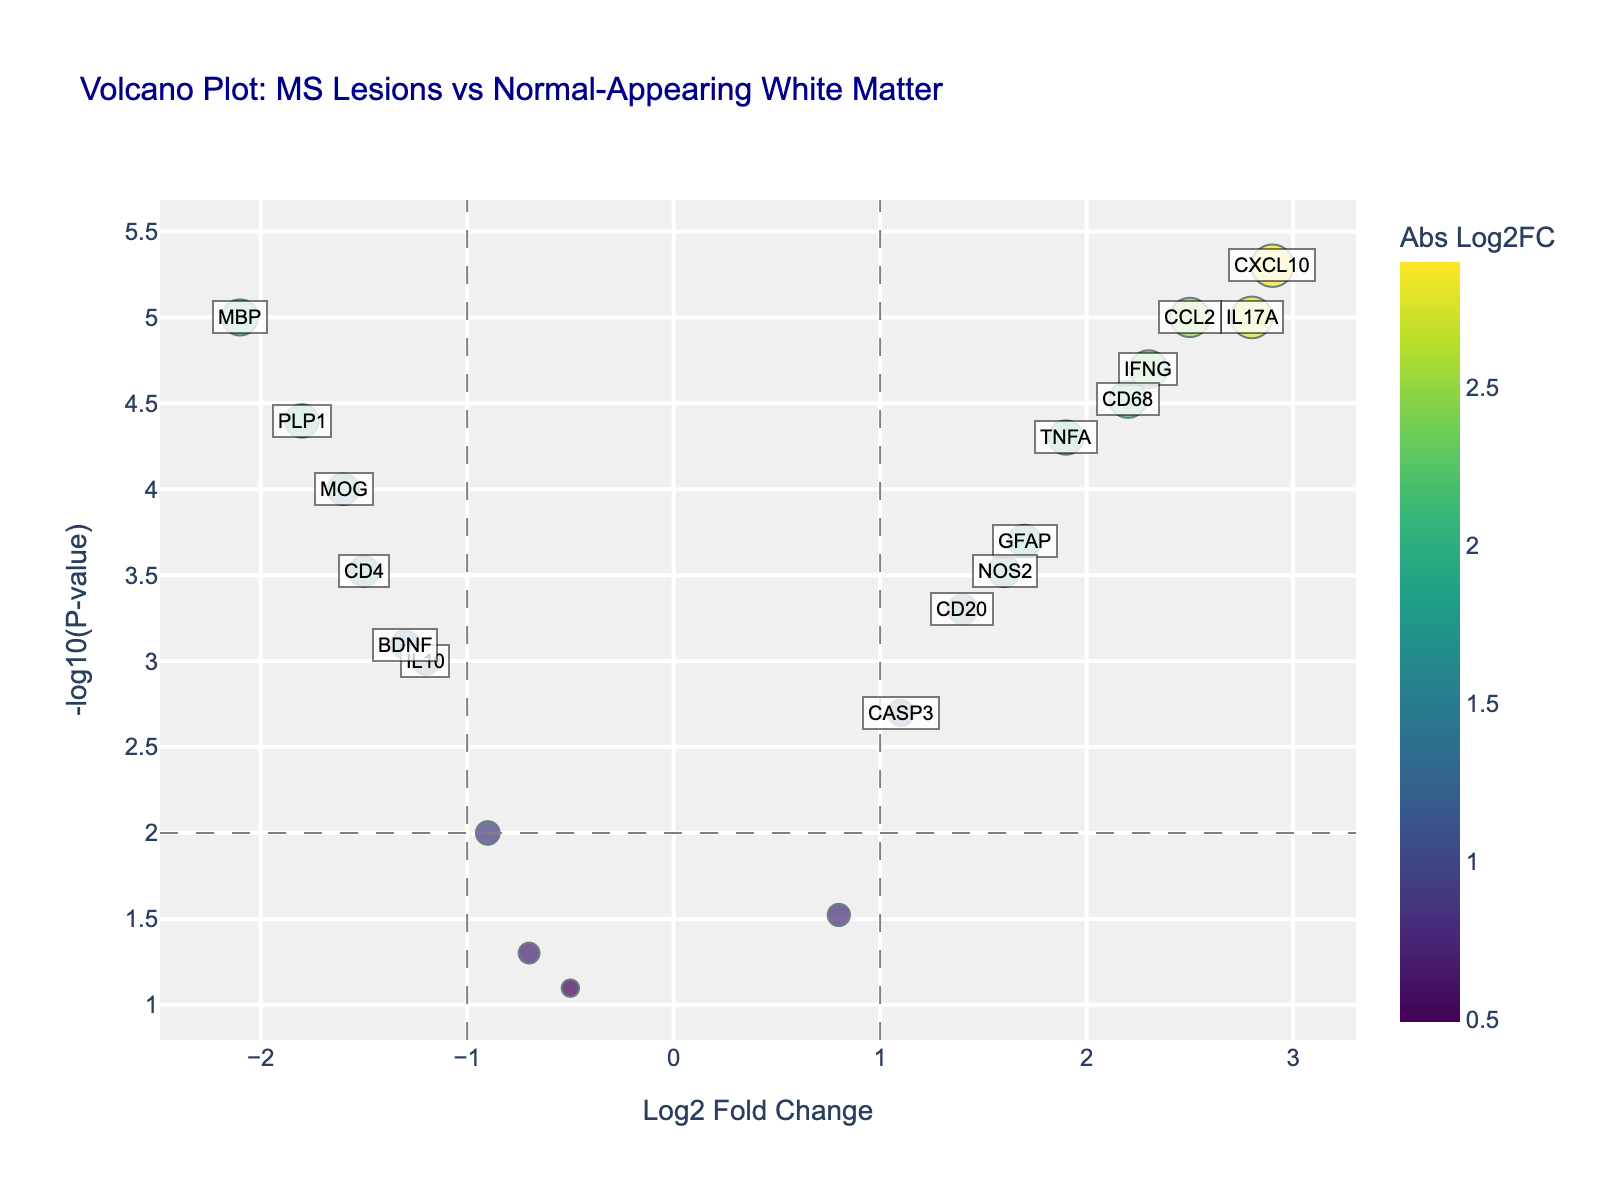What's the title of the plot? The title of the plot is displayed at the top of the figure. By looking at this position, we can see the title specified for the volcano plot.
Answer: Volcano Plot: MS Lesions vs Normal-Appearing White Matter How many genes have a log2 fold change greater than 1? On the horizontal axis, we see the genes distributed based on their log2 fold changes. Genes with a value greater than 1 are those to the right of the vertical threshold line at x=1. Counting these points provides the answer.
Answer: 7 Which gene has the highest -log10(p-value)? By identifying the point that is plotted highest on the vertical axis, we can find the gene with the maximum -log10(p-value). The hover text or annotations can confirm the gene's name.
Answer: CXCL10 Are there any genes with a -log10(p-value) less than 2? The horizontal axis allows us to see the values plotted. We need to check for any points that fall below the threshold line at y=2 to find these genes.
Answer: Yes What is the log2 fold change of the gene CD4? Locate the gene CD4 on the plot and refer to its position on the horizontal axis, which represents the log2 fold change. The hover text may also provide this information.
Answer: -1.5 Which gene has the lowest log2 fold change? By identifying the point furthest to the left on the x-axis, we can determine the gene with the lowest log2 fold change. The hover text or annotations can help confirm the gene's name.
Answer: MBP How many genes have a significant p-value (p<0.05)? On the vertical axis, a significant p-value translates to a -log10(p-value) greater than approximately 1.3. Counting all points above this value will give the total number of significant genes.
Answer: 18 Compare the log2 fold change of IL17A and TNFA. Which one is higher? By locating both IL17A and TNFA on the plot and comparing their positions on the horizontal axis, we can determine which gene has a higher log2 fold change.
Answer: IL17A What is the general trend shown in the plot? Observing the distribution of points can help discern if there is a particular trend. For example, whether more genes tend to have positive or negative log2 fold changes, and how closely these correspond to low p-values.
Answer: More genes tend to show positive log2 fold changes with low p-values What is the -log10(p-value) threshold for significance indicated in the plot? The plot has a horizontal line representing the significance threshold for -log10(p-value). Checking the value of this line on the vertical axis will reveal the threshold.
Answer: 2 